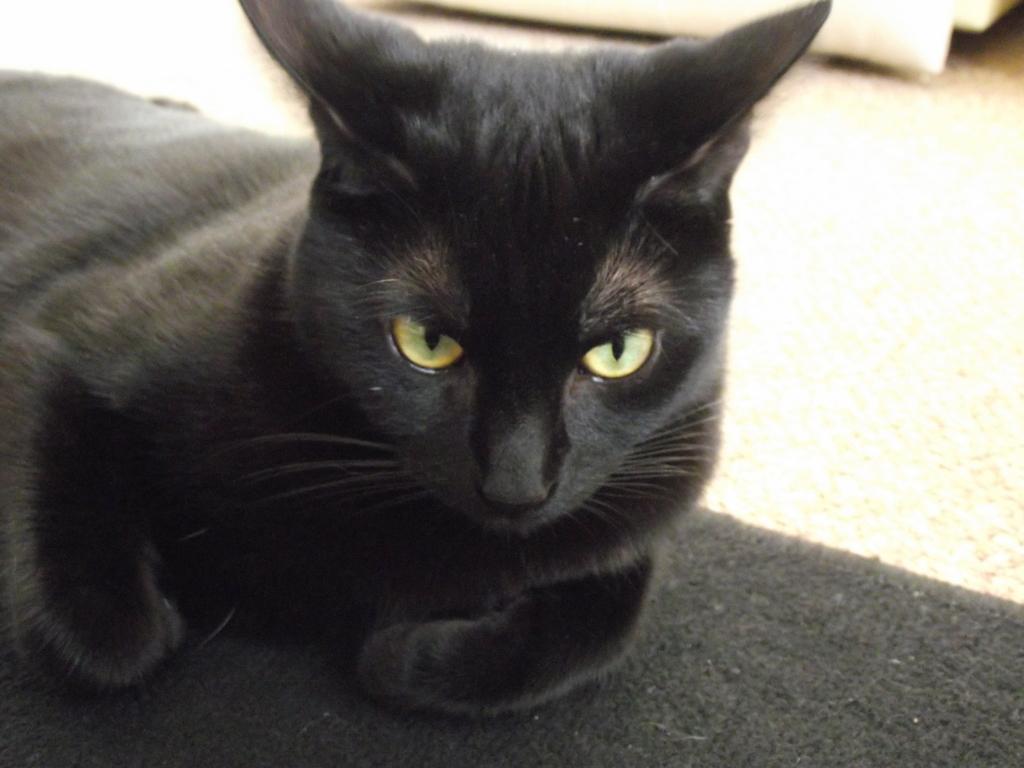Please provide a concise description of this image. In the center of the image a cat is present on the mat. In the background of the image we can see a floor. 